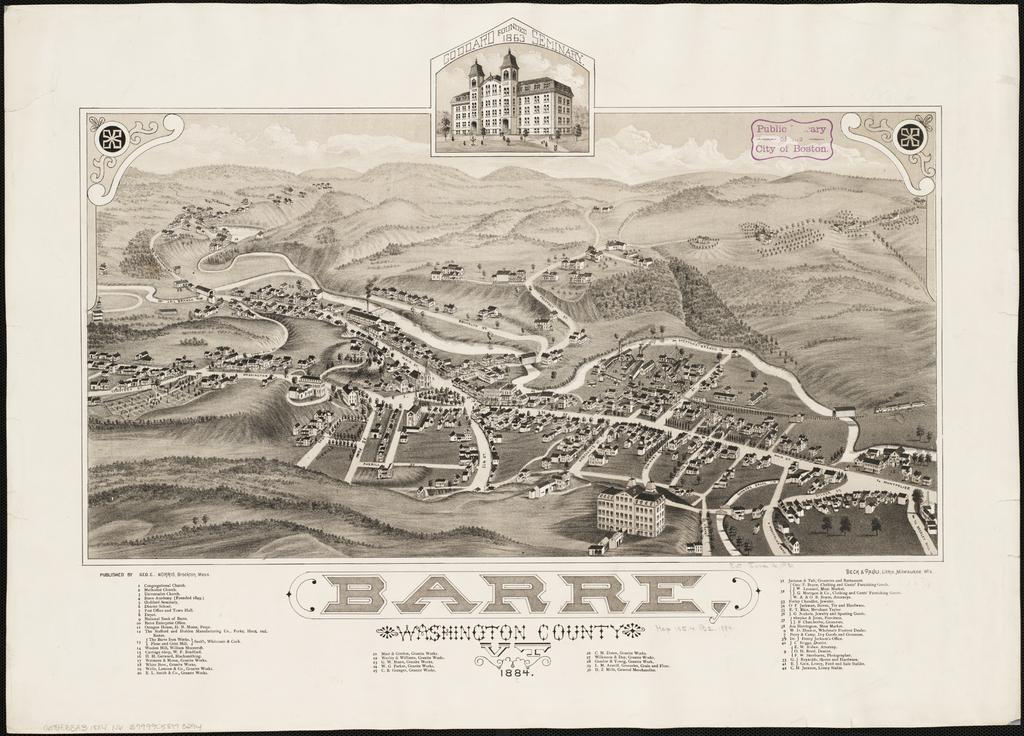<image>
Give a short and clear explanation of the subsequent image. A map with the caption Barre Washington County. 